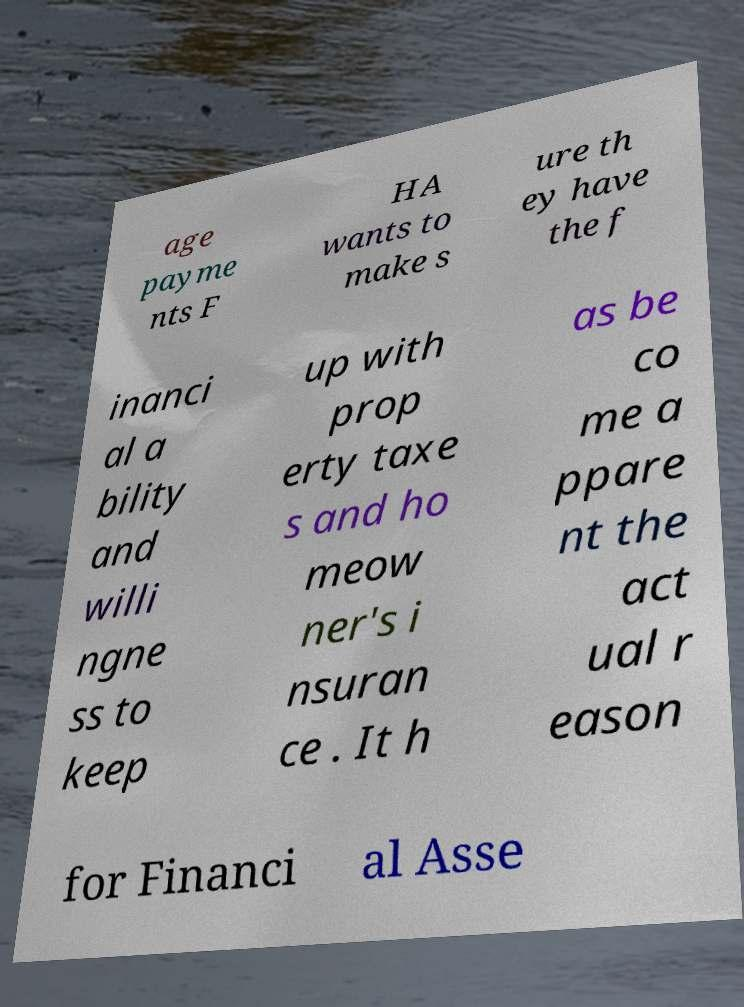What messages or text are displayed in this image? I need them in a readable, typed format. age payme nts F HA wants to make s ure th ey have the f inanci al a bility and willi ngne ss to keep up with prop erty taxe s and ho meow ner's i nsuran ce . It h as be co me a ppare nt the act ual r eason for Financi al Asse 